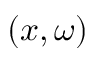Convert formula to latex. <formula><loc_0><loc_0><loc_500><loc_500>( x , \omega )</formula> 